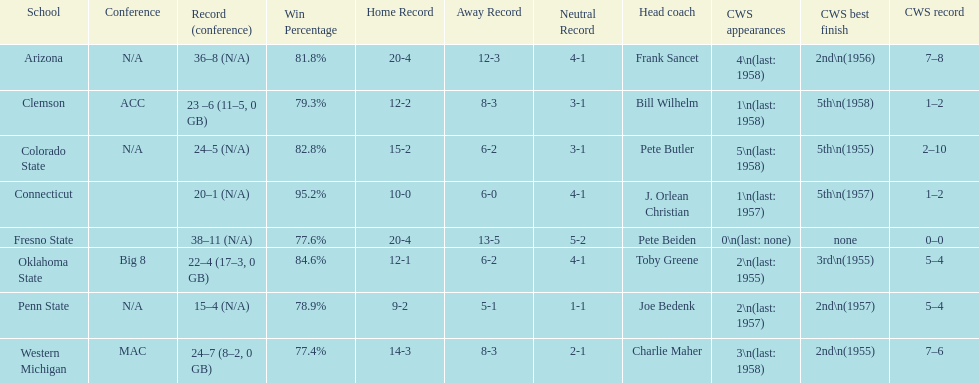List the schools that came in last place in the cws best finish. Clemson, Colorado State, Connecticut. 